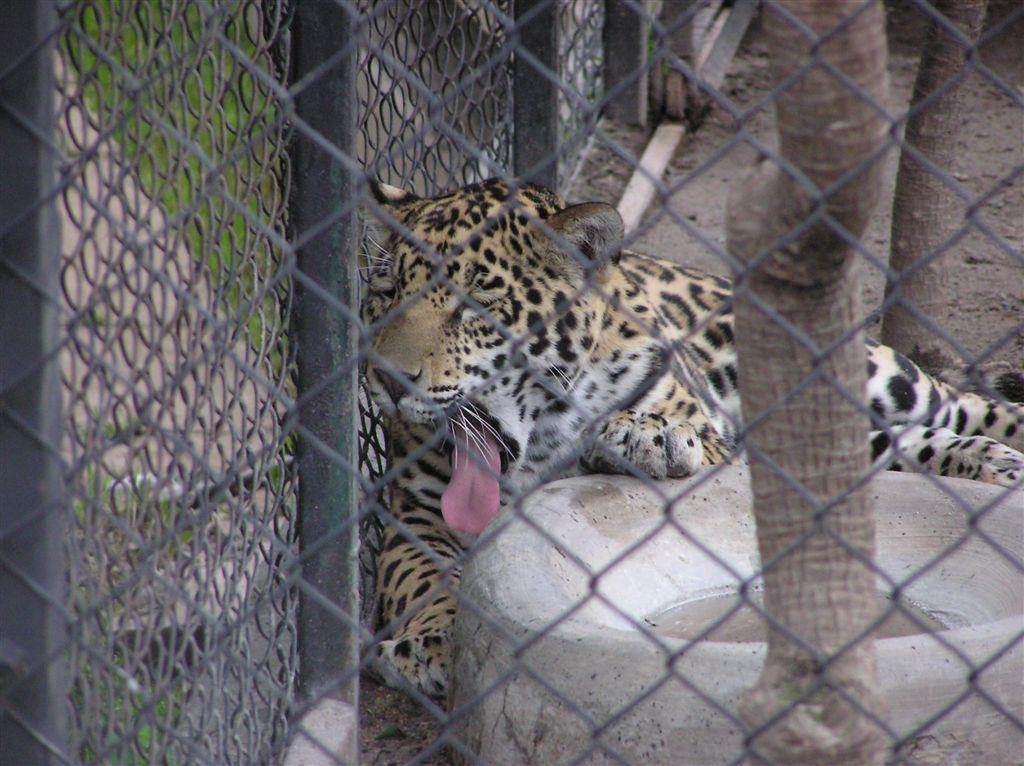Please provide a concise description of this image. In front of the image there is mesh. Behind the mesh there is a tiger on the ground and also there is an object with water in it. There are tree trunks. Beside the tiger there is mesh. 